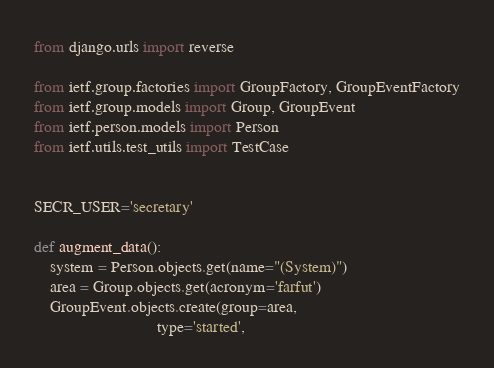<code> <loc_0><loc_0><loc_500><loc_500><_Python_>from django.urls import reverse

from ietf.group.factories import GroupFactory, GroupEventFactory
from ietf.group.models import Group, GroupEvent
from ietf.person.models import Person
from ietf.utils.test_utils import TestCase


SECR_USER='secretary'

def augment_data():
    system = Person.objects.get(name="(System)")
    area = Group.objects.get(acronym='farfut')
    GroupEvent.objects.create(group=area,
                              type='started',</code> 